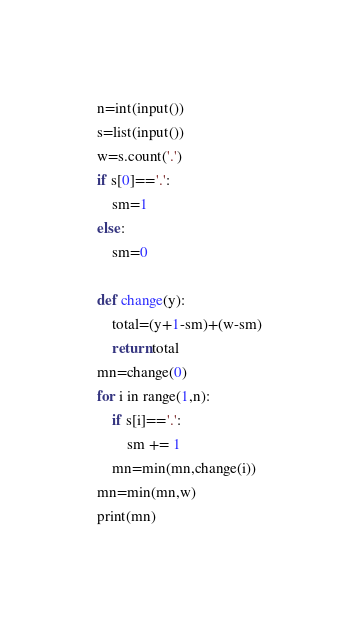<code> <loc_0><loc_0><loc_500><loc_500><_Python_>n=int(input())
s=list(input())
w=s.count('.')
if s[0]=='.':
    sm=1
else:
    sm=0

def change(y):
    total=(y+1-sm)+(w-sm)
    return total
mn=change(0)
for i in range(1,n):
    if s[i]=='.':
        sm += 1
    mn=min(mn,change(i))
mn=min(mn,w)
print(mn)</code> 